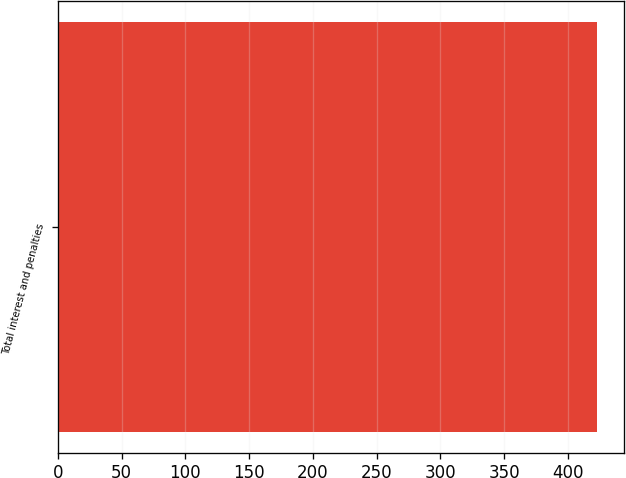<chart> <loc_0><loc_0><loc_500><loc_500><bar_chart><fcel>Total interest and penalties<nl><fcel>422.9<nl></chart> 